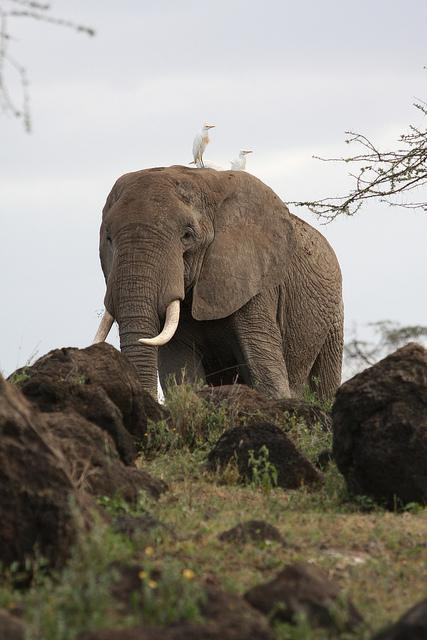What is in front of the elephant's tusks? Please explain your reasoning. rocks. He is standing in front of rocks 